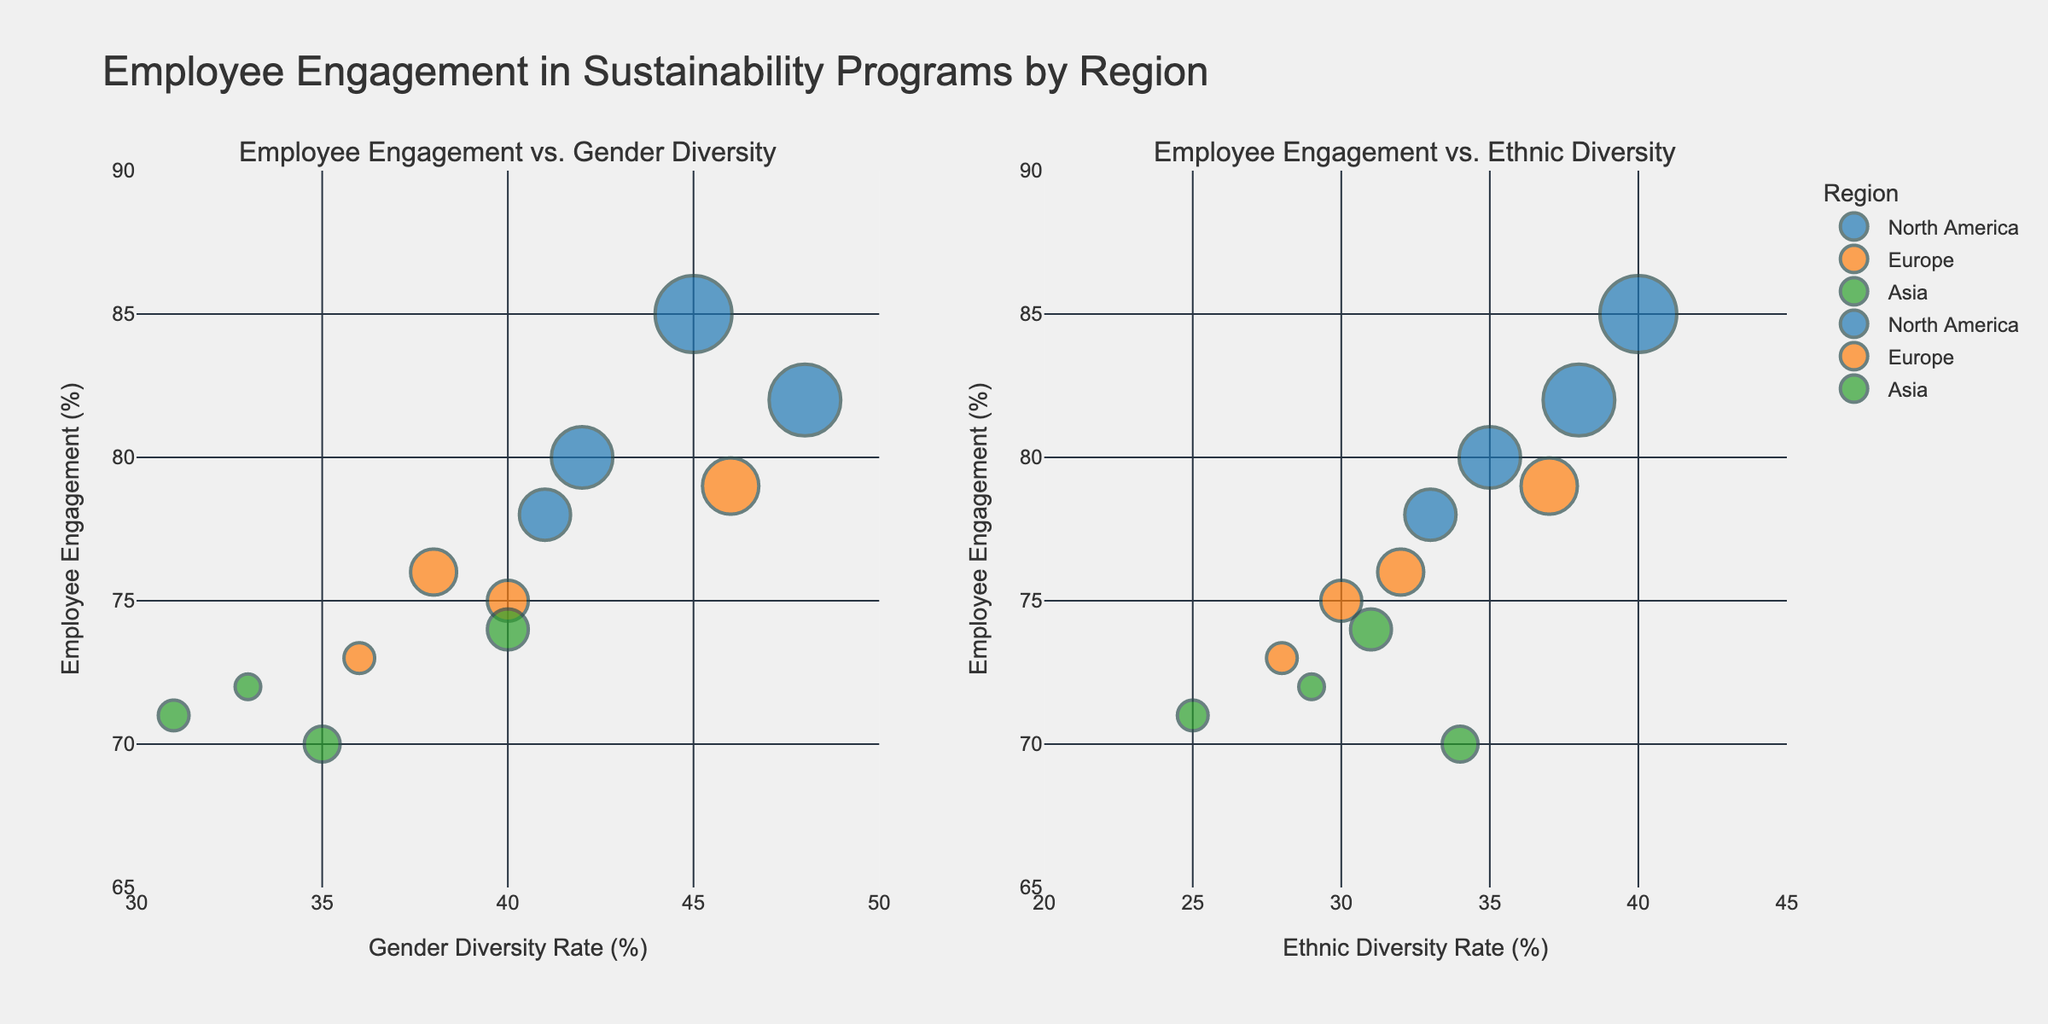what is the title of the figure? The title of the figure is usually displayed at the top center of the plot.
Answer: "Employee Engagement in Sustainability Programs by Region" How many regions are represented in the figure? The plot legend or the different colors representing groups show the number of regions.
Answer: 3 Which region has the highest employee engagement rate? Look for the highest value on the y-axis (Employee Engagement) and identify which region it corresponds to based on the color or legend.
Answer: North America What is the gender diversity rate for the company with the highest employee engagement? Identify the highest employee engagement rate and trace its x-coordinate in the subplot titled "Employee Engagement vs. Gender Diversity".
Answer: 45 How does the average sustainability training hours correlate with bubble size? The size of each bubble on the plot is proportional to the average sustainability training hours, with larger bubbles representing higher values.
Answer: Larger bubbles correlate with more training hours Among companies in North America, which has the lowest ethnic diversity rate? Look at the bubbles in the North American color in the "Employee Engagement vs. Ethnic Diversity" subplot and find the one with the lowest x-axis value.
Answer: Amazon Which company in Europe has the highest employee engagement with respect to gender diversity? In the "Employee Engagement vs. Gender Diversity" subplot, identify the bubble with the highest y-value that is colored for Europe.
Answer: Unilever What is the employee engagement rate for the company with the highest ethnic diversity rate? Find the bubble with the highest x-coordinate in the "Employee Engagement vs. Ethnic Diversity" subplot and note its y-value.
Answer: 82 What can be inferred about the relationship between gender diversity and employee engagement in North America? By observing the overall trend and spread of the North American bubbles in the "Employee Engagement vs. Gender Diversity" subplot, one can infer the general relationship.
Answer: Generally positive Is there a region where employee engagement appears to be consistent irrespective of either diversity metric? Compare the clustering of bubbles for each region in terms of y-values across both subplots.
Answer: Europe Among companies in Asia, which has the highest average sustainability training hours? Look at the largest bubble in the subplots that is colored for Asia.
Answer: Alibaba 